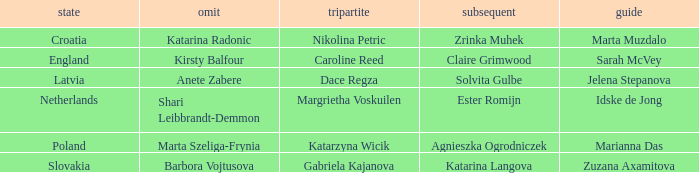Who is the Second with Nikolina Petric as Third? Zrinka Muhek. 